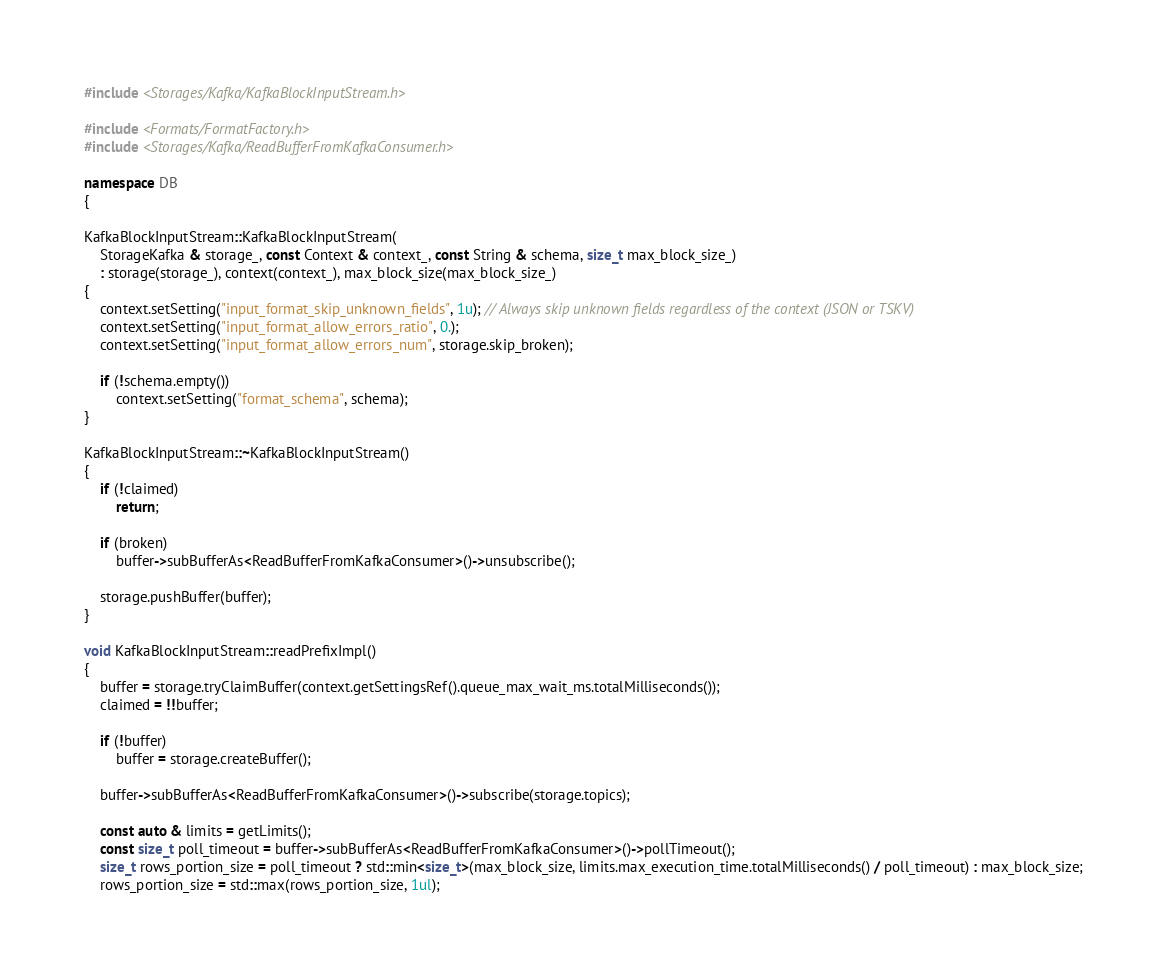<code> <loc_0><loc_0><loc_500><loc_500><_C++_>#include <Storages/Kafka/KafkaBlockInputStream.h>

#include <Formats/FormatFactory.h>
#include <Storages/Kafka/ReadBufferFromKafkaConsumer.h>

namespace DB
{

KafkaBlockInputStream::KafkaBlockInputStream(
    StorageKafka & storage_, const Context & context_, const String & schema, size_t max_block_size_)
    : storage(storage_), context(context_), max_block_size(max_block_size_)
{
    context.setSetting("input_format_skip_unknown_fields", 1u); // Always skip unknown fields regardless of the context (JSON or TSKV)
    context.setSetting("input_format_allow_errors_ratio", 0.);
    context.setSetting("input_format_allow_errors_num", storage.skip_broken);

    if (!schema.empty())
        context.setSetting("format_schema", schema);
}

KafkaBlockInputStream::~KafkaBlockInputStream()
{
    if (!claimed)
        return;

    if (broken)
        buffer->subBufferAs<ReadBufferFromKafkaConsumer>()->unsubscribe();

    storage.pushBuffer(buffer);
}

void KafkaBlockInputStream::readPrefixImpl()
{
    buffer = storage.tryClaimBuffer(context.getSettingsRef().queue_max_wait_ms.totalMilliseconds());
    claimed = !!buffer;

    if (!buffer)
        buffer = storage.createBuffer();

    buffer->subBufferAs<ReadBufferFromKafkaConsumer>()->subscribe(storage.topics);

    const auto & limits = getLimits();
    const size_t poll_timeout = buffer->subBufferAs<ReadBufferFromKafkaConsumer>()->pollTimeout();
    size_t rows_portion_size = poll_timeout ? std::min<size_t>(max_block_size, limits.max_execution_time.totalMilliseconds() / poll_timeout) : max_block_size;
    rows_portion_size = std::max(rows_portion_size, 1ul);
</code> 